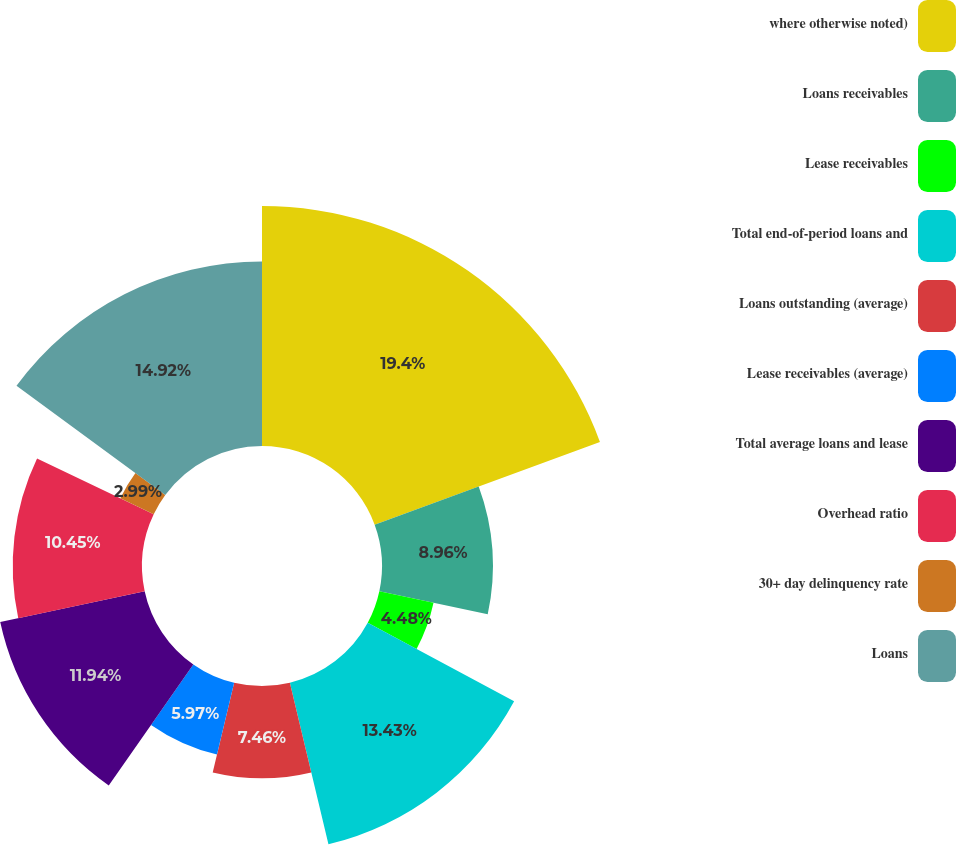<chart> <loc_0><loc_0><loc_500><loc_500><pie_chart><fcel>where otherwise noted)<fcel>Loans receivables<fcel>Lease receivables<fcel>Total end-of-period loans and<fcel>Loans outstanding (average)<fcel>Lease receivables (average)<fcel>Total average loans and lease<fcel>Overhead ratio<fcel>30+ day delinquency rate<fcel>Loans<nl><fcel>19.4%<fcel>8.96%<fcel>4.48%<fcel>13.43%<fcel>7.46%<fcel>5.97%<fcel>11.94%<fcel>10.45%<fcel>2.99%<fcel>14.92%<nl></chart> 